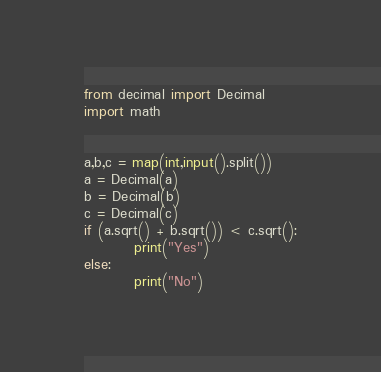Convert code to text. <code><loc_0><loc_0><loc_500><loc_500><_Python_>from decimal import Decimal
import math


a,b,c = map(int,input().split())
a = Decimal(a)
b = Decimal(b)
c = Decimal(c)
if (a.sqrt() + b.sqrt()) < c.sqrt():
         print("Yes")
else:
         print("No")
</code> 